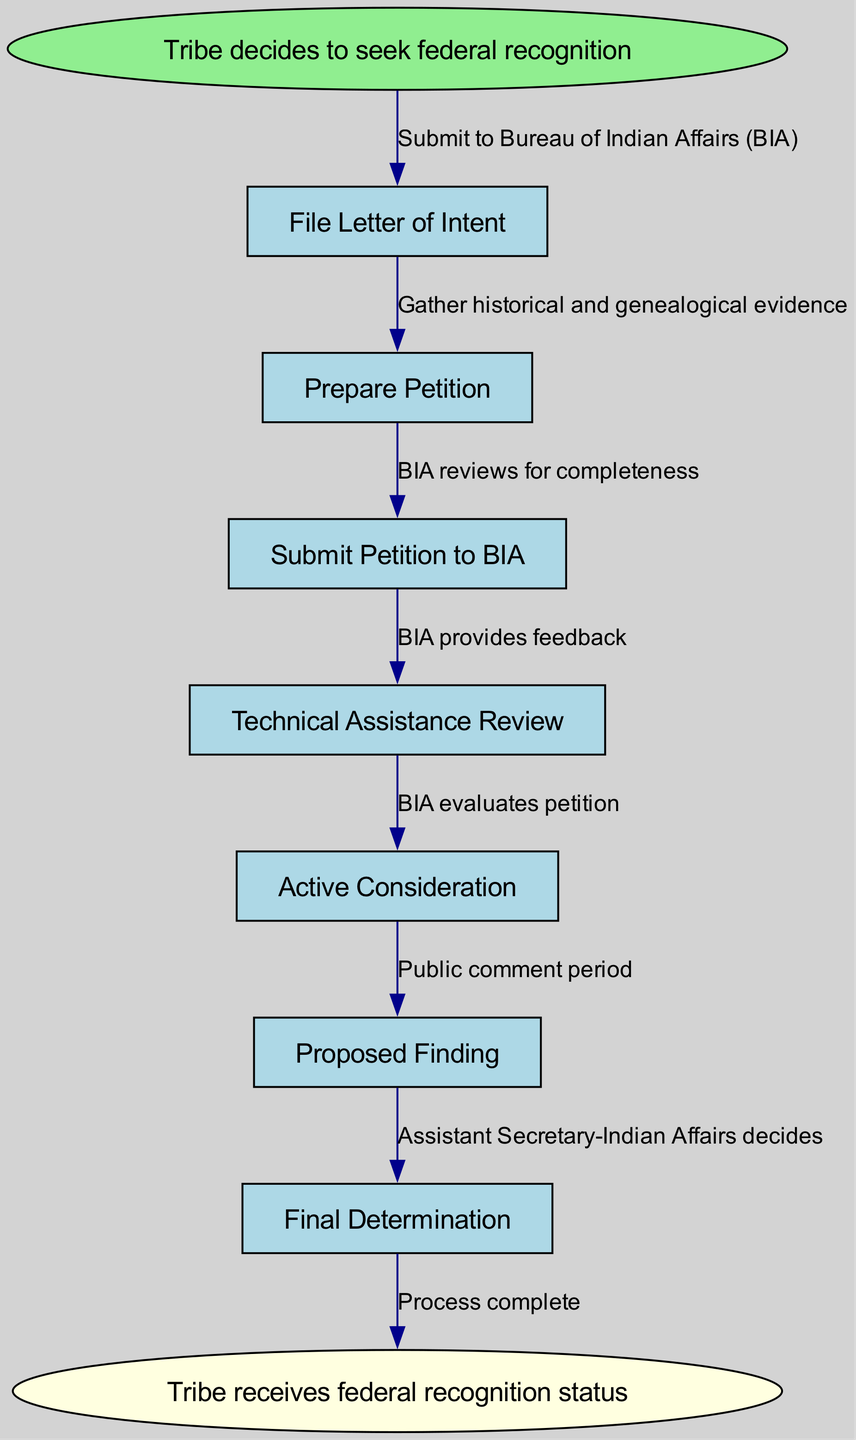What is the first step in the federal recognition process? The first step, as indicated in the diagram, is to "File Letter of Intent." This is the starting action that the tribe takes in seeking federal recognition.
Answer: File Letter of Intent How many steps are there in the federal recognition process? The diagram outlines a total of 7 steps from the initial filing to receiving federal recognition, counting each specific action as a distinct step.
Answer: 7 What does the BIA do after the petition is submitted? After the petition is submitted to the Bureau of Indian Affairs, it reviews the petition for completeness, which is essential for determining if the petition meets the initial criteria for consideration.
Answer: BIA reviews for completeness What follows the Technical Assistance Review step? The step that comes after the Technical Assistance Review, where BIA provides feedback, is the "Active Consideration" step where the BIA evaluates the petition further based on the provided information and feedback.
Answer: Active Consideration What is the final decision maker in the process? The final decision regarding federal recognition is made by the Assistant Secretary-Indian Affairs, as indicated in the last part of the process in the diagram.
Answer: Assistant Secretary-Indian Affairs During which step is public feedback gathered? Public feedback is collected during the "Proposed Finding" step, which includes a public comment period to gather input from the community and stakeholders regarding the tribe's petition for federal recognition.
Answer: Proposed Finding What indicates the end of the process? The end of the process is indicated by the node "Tribe receives federal recognition status", which signifies that all previous steps have been completed successfully and the tribe is officially recognized.
Answer: Tribe receives federal recognition status 